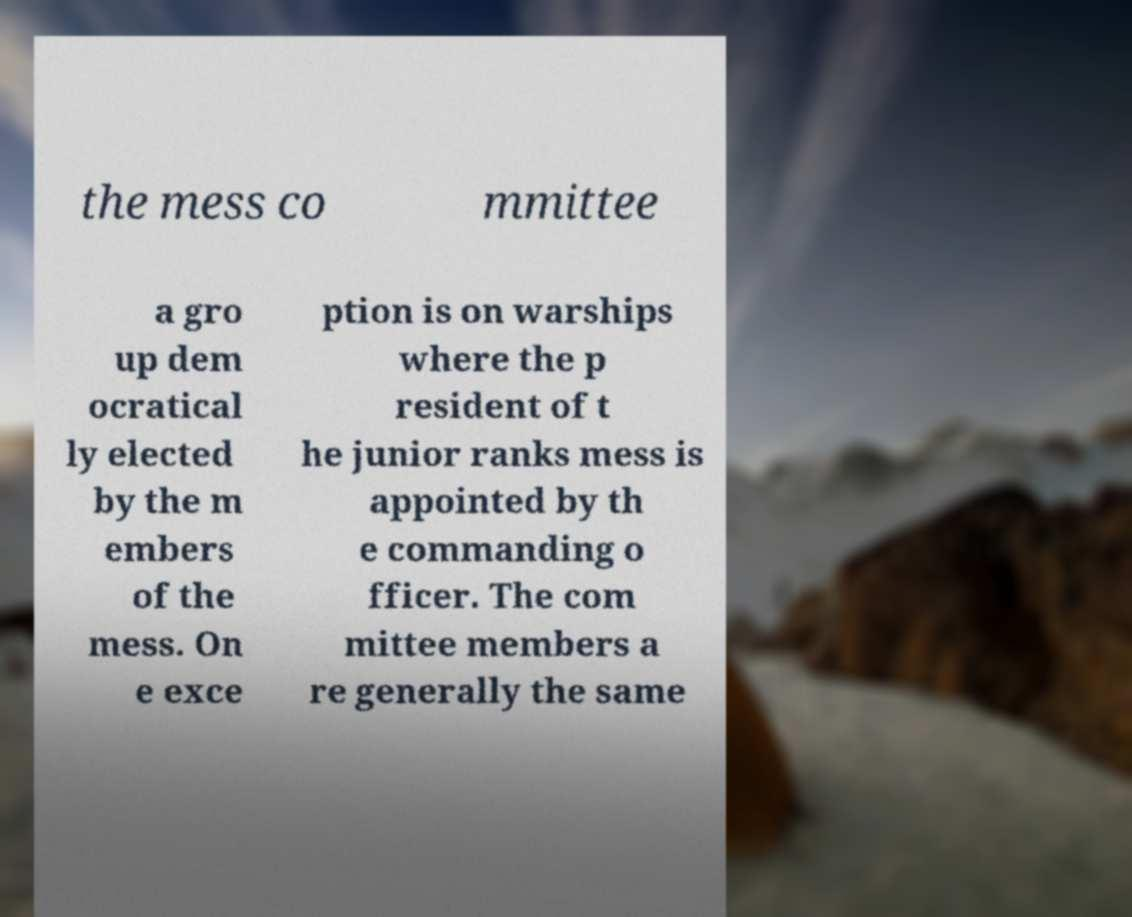For documentation purposes, I need the text within this image transcribed. Could you provide that? the mess co mmittee a gro up dem ocratical ly elected by the m embers of the mess. On e exce ption is on warships where the p resident of t he junior ranks mess is appointed by th e commanding o fficer. The com mittee members a re generally the same 